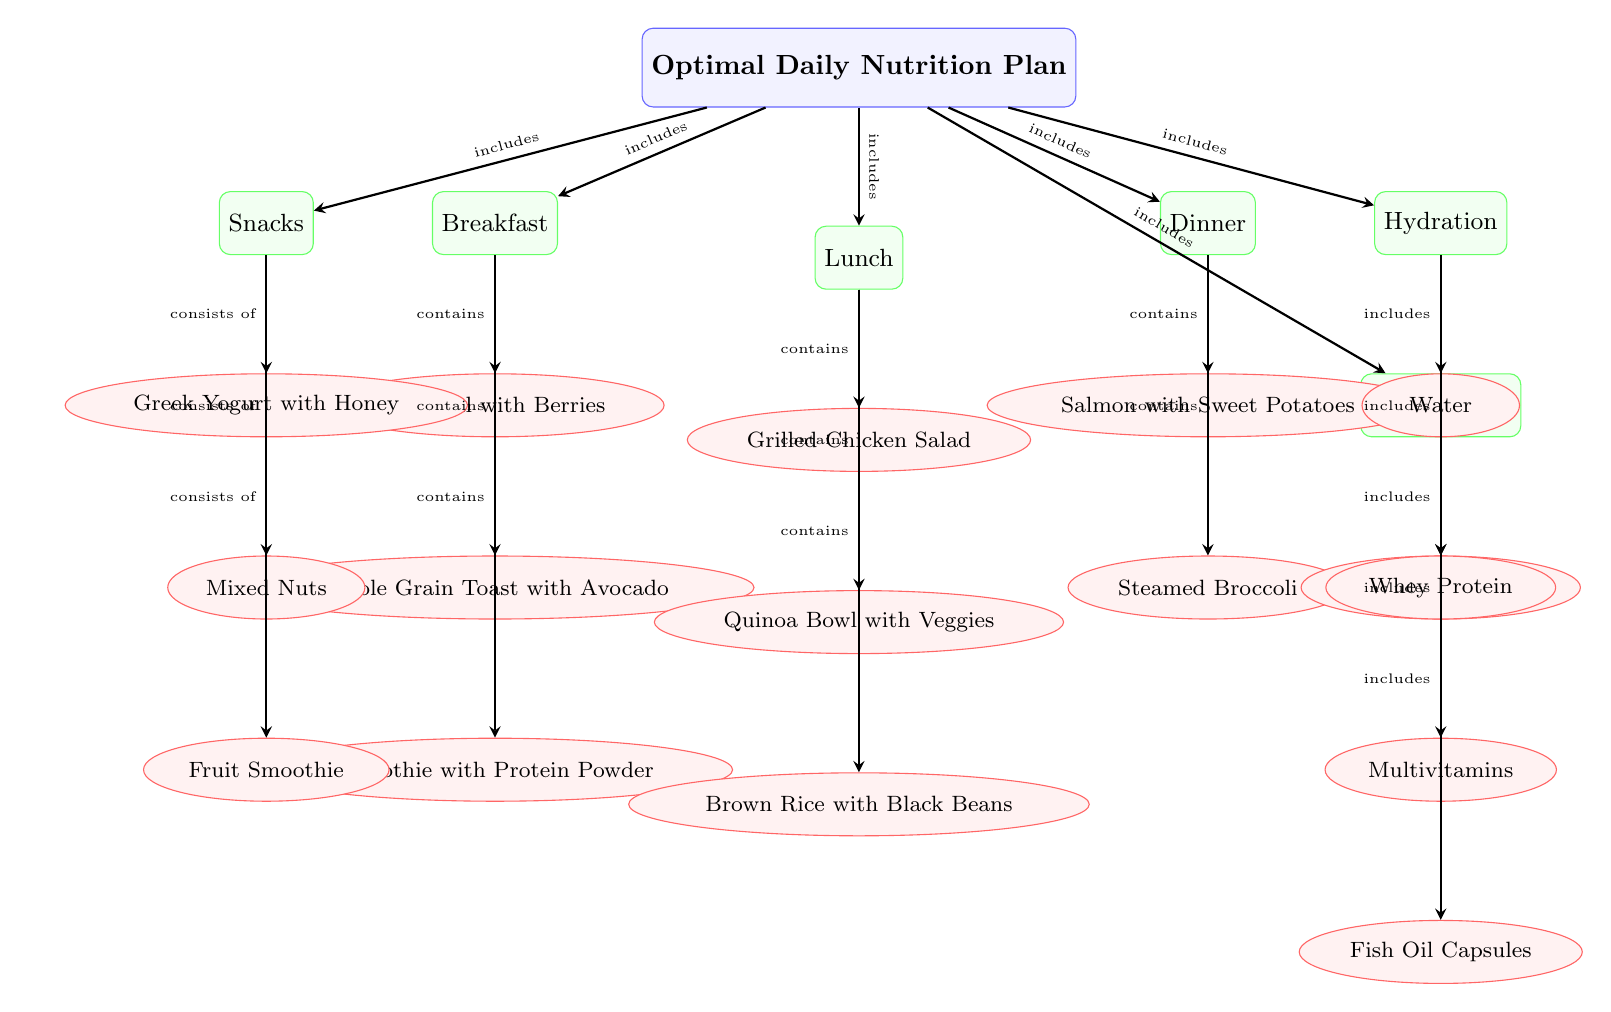What are the main meal categories included in the optimal nutrition plan? The diagram lists three main meal categories: Breakfast, Lunch, and Dinner. These nodes are directly connected to the main node titled "Optimal Daily Nutrition Plan," indicating their inclusion in the plan.
Answer: Breakfast, Lunch, Dinner How many items are included in breakfast? By examining the nodes connected to the "Breakfast" subnode, we can see three items: Oatmeal with Berries, Whole Grain Toast with Avocado, and Smoothie with Protein Powder.
Answer: 3 What type of drink is included in the hydration category? The "Hydration" subnode leads to two item nodes: Water and Electrolyte Drink. Both of these fulfill the role of beverages within this category.
Answer: Water, Electrolyte Drink Which meals contain a protein source? Looking at the meals, "Grilled Chicken Salad" in Lunch and "Salmon with Sweet Potatoes" in Dinner both contain substantial protein sources. By identifying nodes under Lunch and Dinner, we can determine these are key meals for protein intake.
Answer: Grilled Chicken Salad, Salmon with Sweet Potatoes What is classified under snacks? The "Snacks" subnode connects to three items: Greek Yogurt with Honey, Mixed Nuts, and Fruit Smoothie, showing that these items are included in the snacks category.
Answer: Greek Yogurt, Mixed Nuts, Fruit Smoothie How many supplements are listed in the nutrition plan? Under the "Supplements" subnode, there are three listed items: Whey Protein, Multivitamins, and Fish Oil Capsules. Counting these gives us the total number of supplements.
Answer: 3 What is the connection between hydration and daily nutrition? The "Hydration" subnode indicates that hydration is a direct component of the "Optimal Daily Nutrition Plan," further emphasizing its importance for athletes' performance and health.
Answer: Direct connection Which meal option includes whole grains? Among the breakfast options, "Whole Grain Toast with Avocado" highlights that whole grains are included, emphasizing a healthy carbohydrate source for energy.
Answer: Whole Grain Toast with Avocado What type of supplements are suggested for elite athletes? The "Supplements" category consists of three items specifically tailored for athlete’s health: Whey Protein, Multivitamins, and Fish Oil Capsules, showcasing a diverse range of nutritional support.
Answer: Whey Protein, Multivitamins, Fish Oil Capsules 